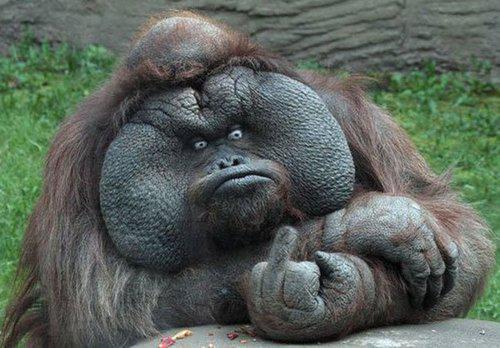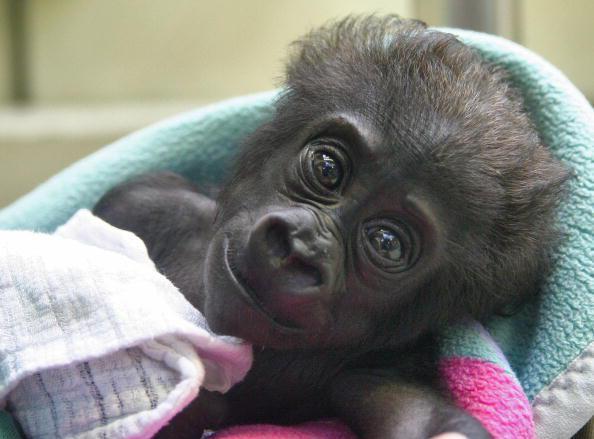The first image is the image on the left, the second image is the image on the right. Considering the images on both sides, is "An animal is looking at the camera and flashing its middle finger in the left image." valid? Answer yes or no. Yes. The first image is the image on the left, the second image is the image on the right. Assess this claim about the two images: "The left image shows a large forward-facing ape with its elbows bent and the hand on the right side flipping up its middle finger.". Correct or not? Answer yes or no. Yes. 